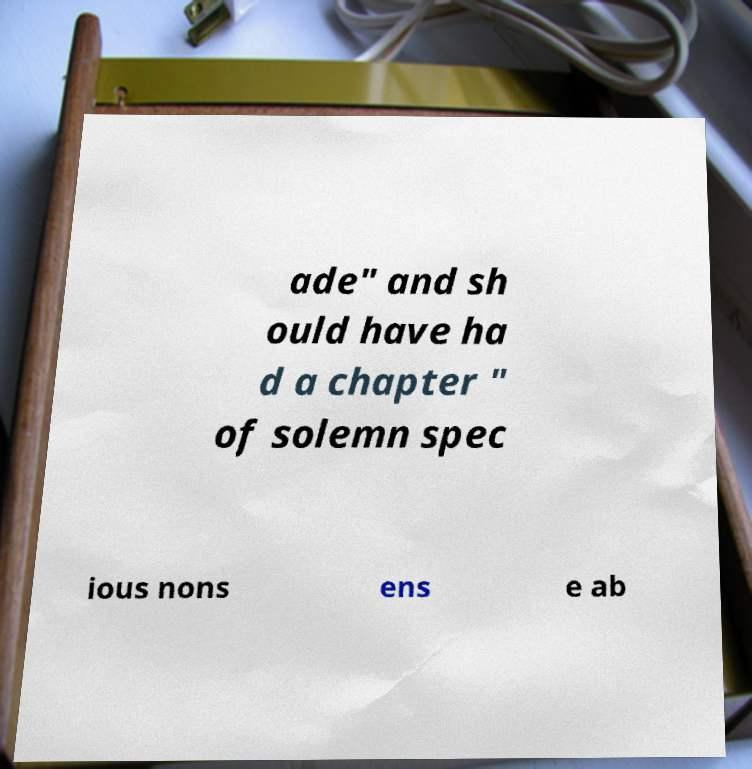Can you accurately transcribe the text from the provided image for me? ade" and sh ould have ha d a chapter " of solemn spec ious nons ens e ab 